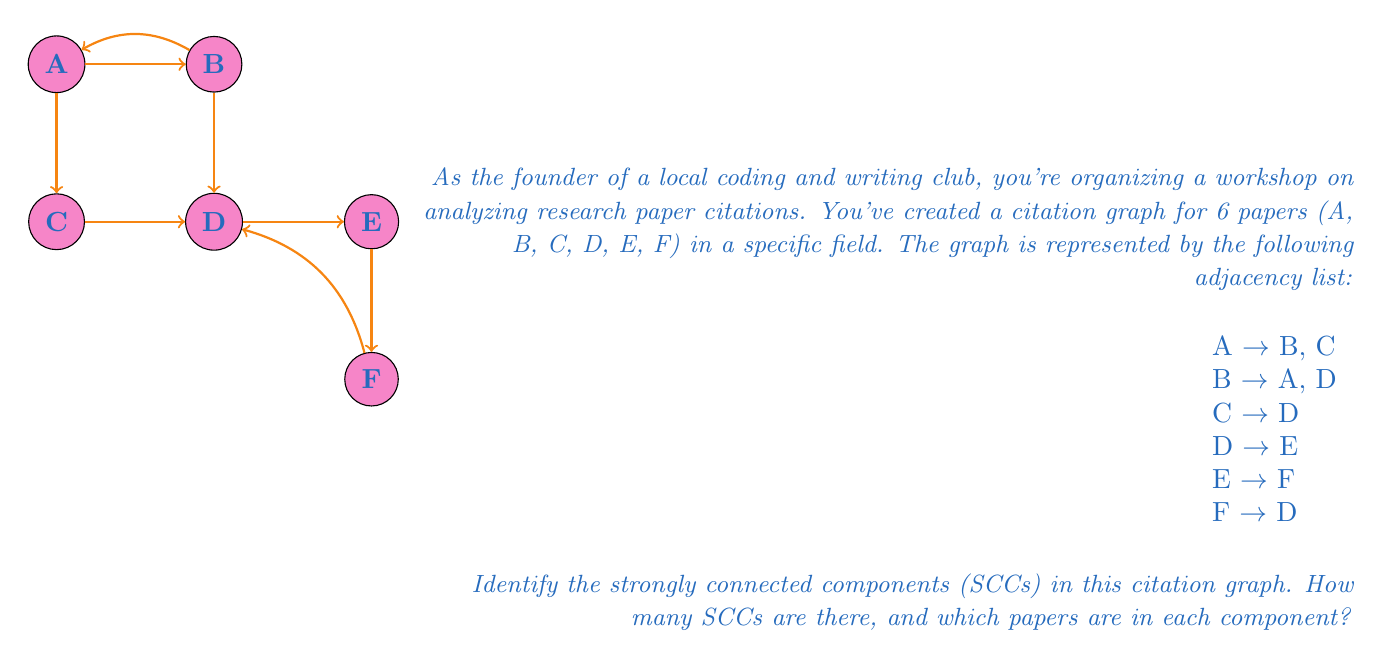Solve this math problem. To identify strongly connected components (SCCs) in a directed graph, we can use Kosaraju's algorithm. This algorithm involves two depth-first search (DFS) passes:

1. First DFS pass:
   - Perform DFS on the original graph
   - Store nodes in a stack as they finish

2. Second DFS pass:
   - Reverse all edges in the graph
   - Perform DFS on reversed graph, starting with nodes from the stack
   - Each DFS tree is a strongly connected component

Let's apply this to our citation graph:

Step 1: First DFS pass
- Start from A: A -> B -> D -> E -> F (stack: F)
- Backtrack to D, no unvisited neighbors (stack: F, D)
- Backtrack to B, no unvisited neighbors (stack: F, D, B)
- Backtrack to A, visit C (stack: F, D, B, C)
- Backtrack to A (stack: F, D, B, C, A)

Step 2: Reverse the graph
Reversed adjacency list:
A <- B
B <- A
C <- A
D <- B, C, F
E <- D
F <- E

Step 3: Second DFS pass
- Start with A (top of stack): A, B
- Next available node C: C
- Next available node D: D, F, E

We find 3 strongly connected components:
1. {A, B}
2. {C}
3. {D, E, F}
Answer: 3 SCCs: {A, B}, {C}, {D, E, F} 